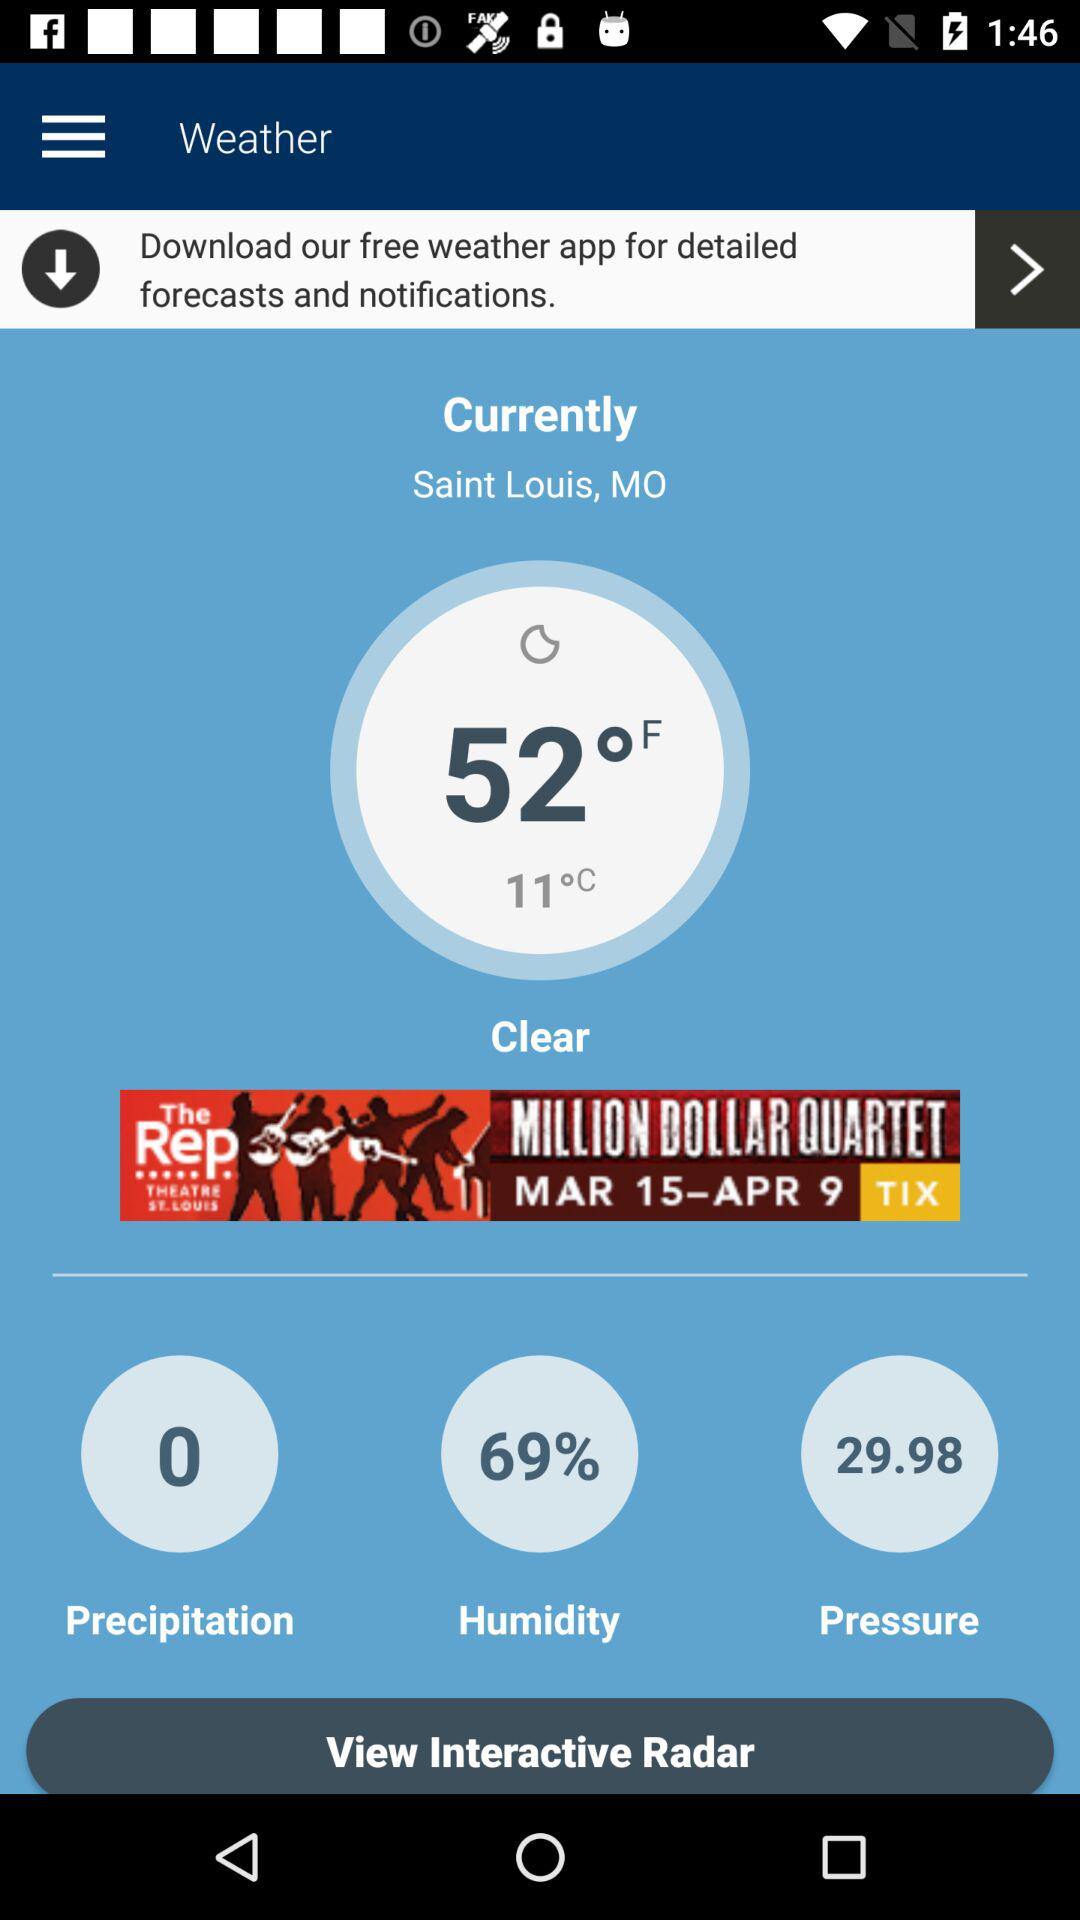What's the current location? The current location is Saint Louis, MO. 